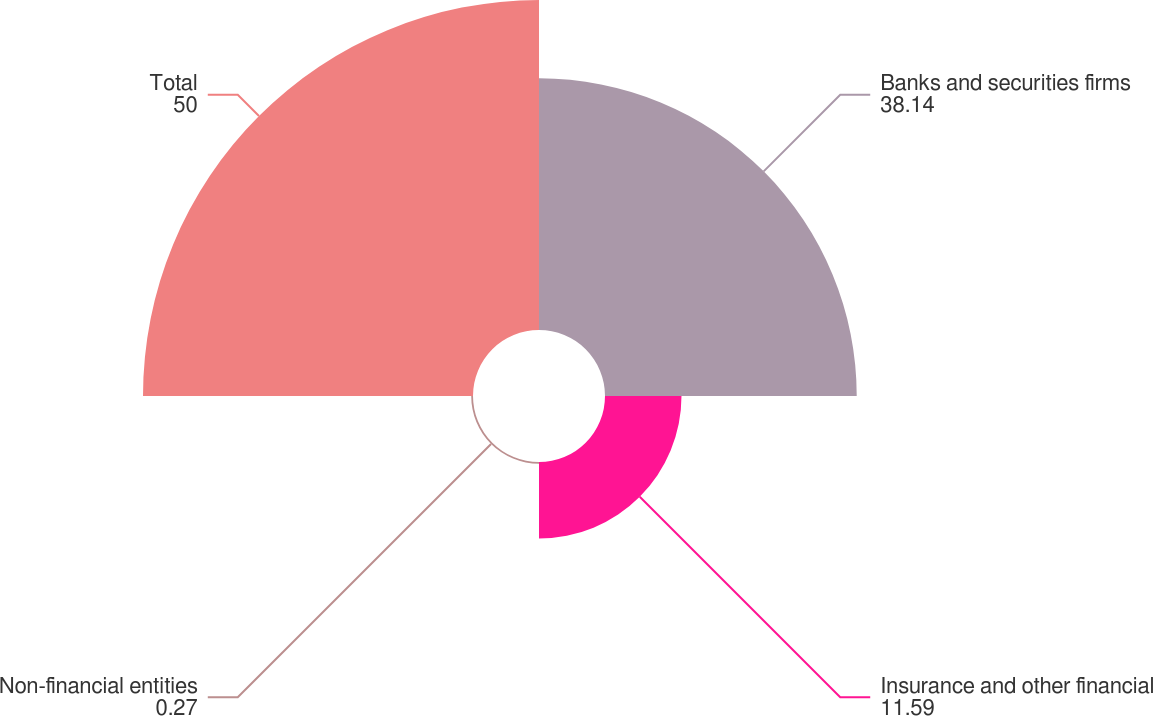Convert chart. <chart><loc_0><loc_0><loc_500><loc_500><pie_chart><fcel>Banks and securities firms<fcel>Insurance and other financial<fcel>Non-financial entities<fcel>Total<nl><fcel>38.14%<fcel>11.59%<fcel>0.27%<fcel>50.0%<nl></chart> 